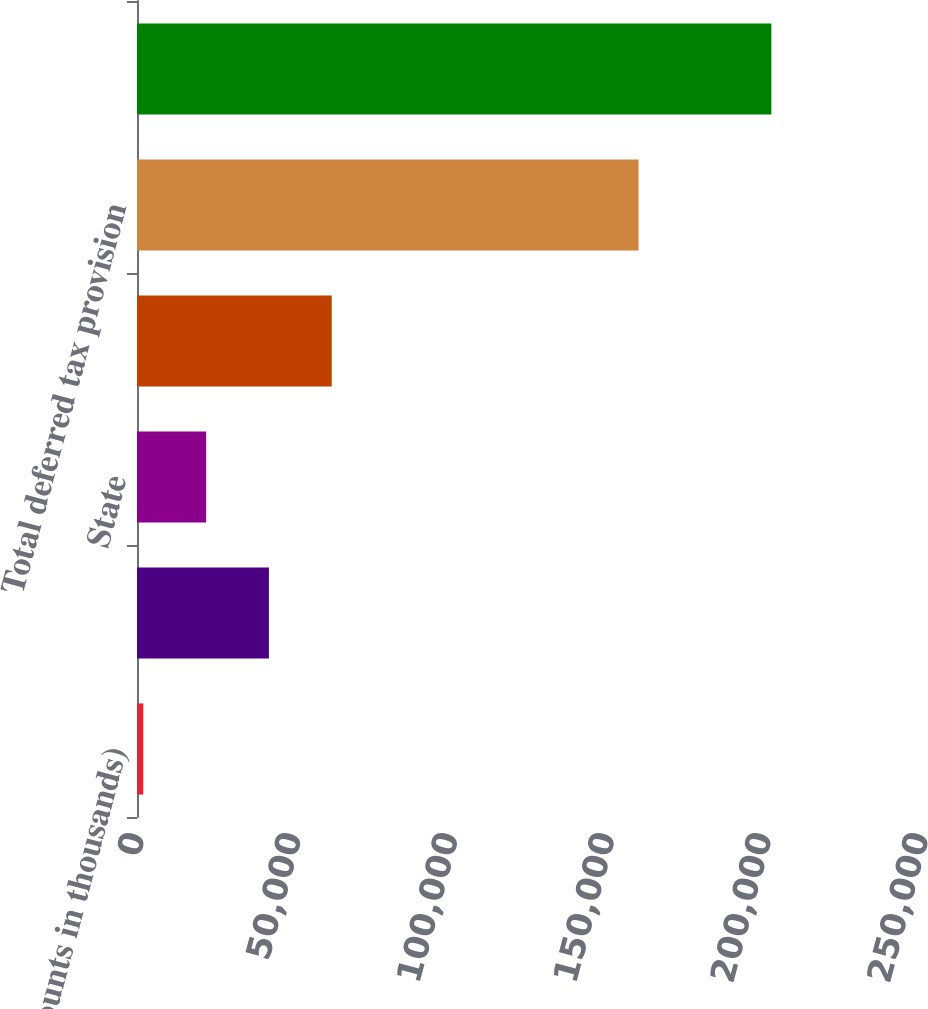<chart> <loc_0><loc_0><loc_500><loc_500><bar_chart><fcel>(dollar amounts in thousands)<fcel>Federal<fcel>State<fcel>Total current tax provision<fcel>Total deferred tax provision<fcel>Provision for income taxes<nl><fcel>2012<fcel>42067.8<fcel>22039.9<fcel>62095.7<fcel>159938<fcel>202291<nl></chart> 